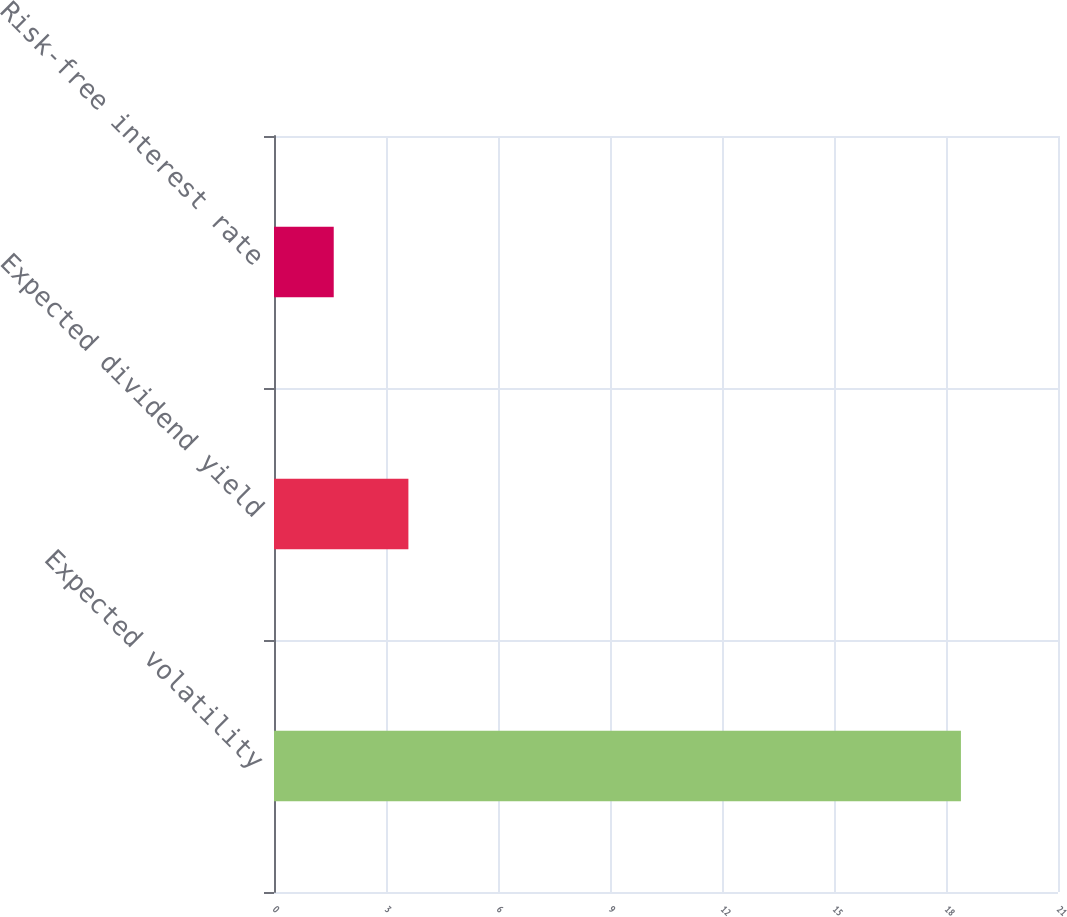<chart> <loc_0><loc_0><loc_500><loc_500><bar_chart><fcel>Expected volatility<fcel>Expected dividend yield<fcel>Risk-free interest rate<nl><fcel>18.4<fcel>3.6<fcel>1.6<nl></chart> 